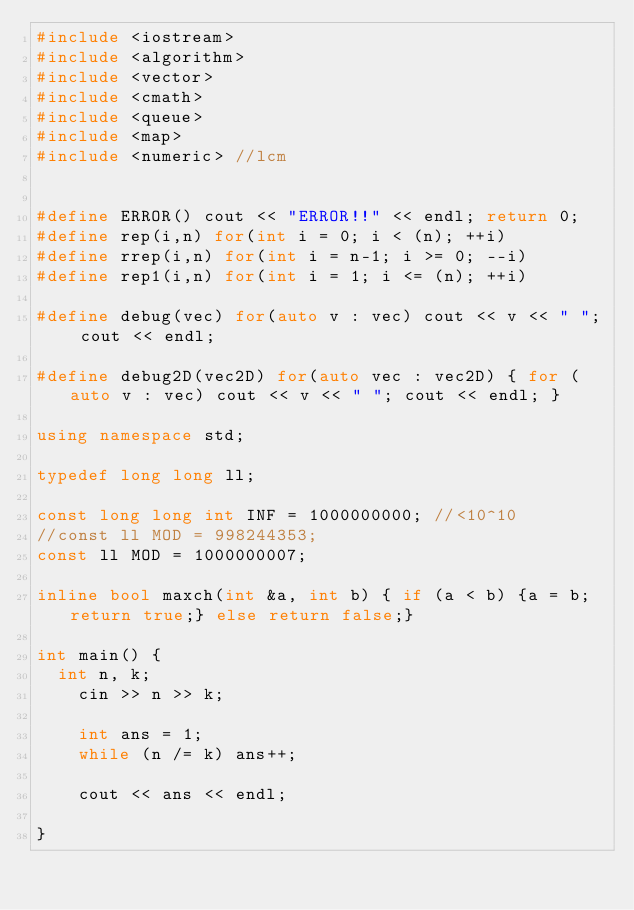<code> <loc_0><loc_0><loc_500><loc_500><_C++_>#include <iostream>
#include <algorithm>
#include <vector>
#include <cmath>
#include <queue>
#include <map>
#include <numeric> //lcm


#define ERROR() cout << "ERROR!!" << endl; return 0;
#define rep(i,n) for(int i = 0; i < (n); ++i)
#define rrep(i,n) for(int i = n-1; i >= 0; --i)
#define rep1(i,n) for(int i = 1; i <= (n); ++i)

#define debug(vec) for(auto v : vec) cout << v << " "; cout << endl;

#define debug2D(vec2D) for(auto vec : vec2D) { for (auto v : vec) cout << v << " "; cout << endl; } 

using namespace std;

typedef long long ll;

const long long int INF = 1000000000; //<10^10
//const ll MOD = 998244353;
const ll MOD = 1000000007;

inline bool maxch(int &a, int b) { if (a < b) {a = b; return true;} else return false;}

int main() {
  int n, k;
	cin >> n >> k;

	int ans = 1;
	while (n /= k) ans++;

	cout << ans << endl;
	
}


</code> 